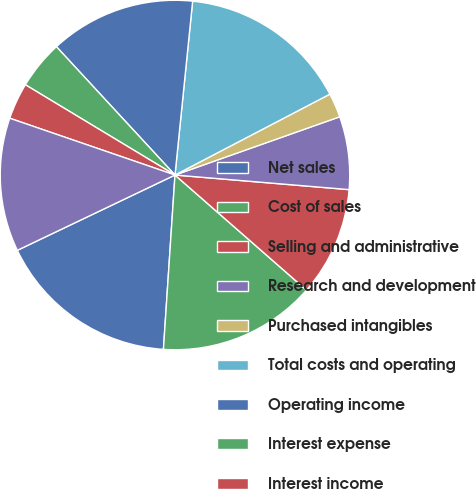Convert chart. <chart><loc_0><loc_0><loc_500><loc_500><pie_chart><fcel>Net sales<fcel>Cost of sales<fcel>Selling and administrative<fcel>Research and development<fcel>Purchased intangibles<fcel>Total costs and operating<fcel>Operating income<fcel>Interest expense<fcel>Interest income<fcel>Income from operations before<nl><fcel>16.85%<fcel>14.61%<fcel>10.11%<fcel>6.74%<fcel>2.25%<fcel>15.73%<fcel>13.48%<fcel>4.49%<fcel>3.37%<fcel>12.36%<nl></chart> 